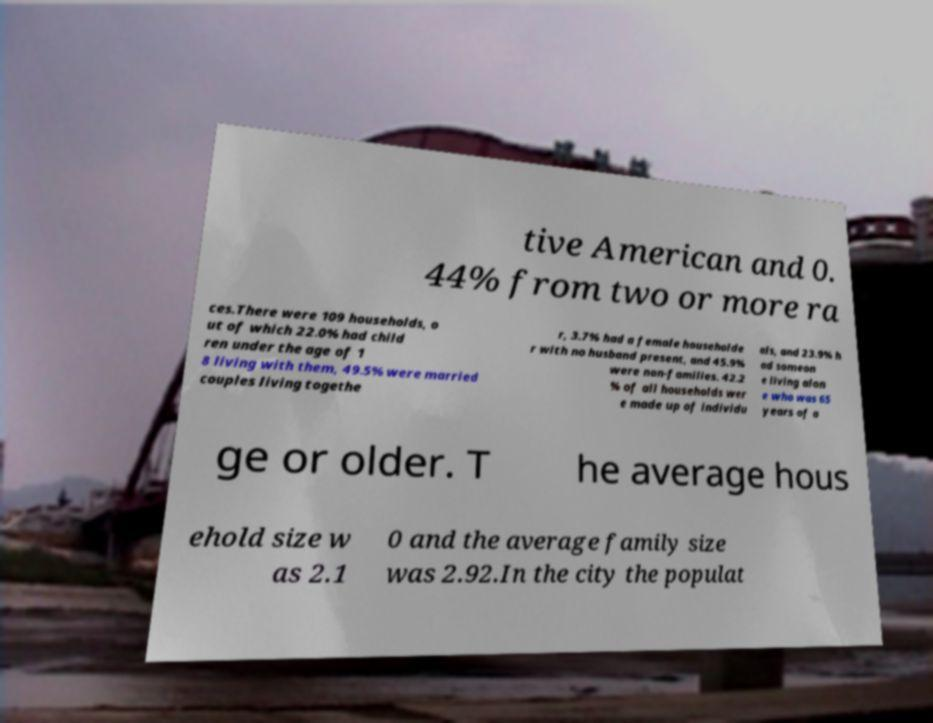Could you extract and type out the text from this image? tive American and 0. 44% from two or more ra ces.There were 109 households, o ut of which 22.0% had child ren under the age of 1 8 living with them, 49.5% were married couples living togethe r, 3.7% had a female householde r with no husband present, and 45.9% were non-families. 42.2 % of all households wer e made up of individu als, and 23.9% h ad someon e living alon e who was 65 years of a ge or older. T he average hous ehold size w as 2.1 0 and the average family size was 2.92.In the city the populat 